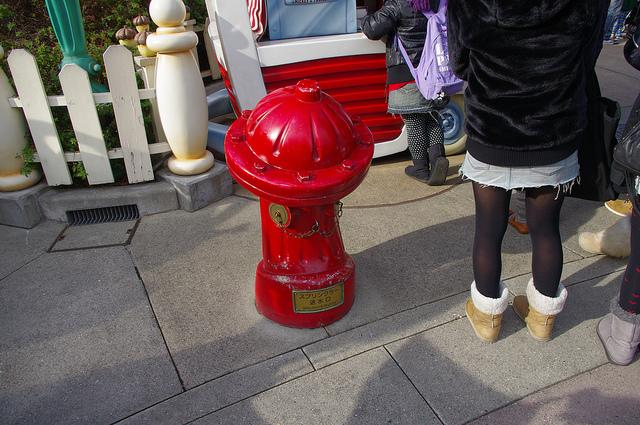What is required to open the flow of water?

Choices:
A) wrench
B) saw
C) hammer
D) drill wrench 